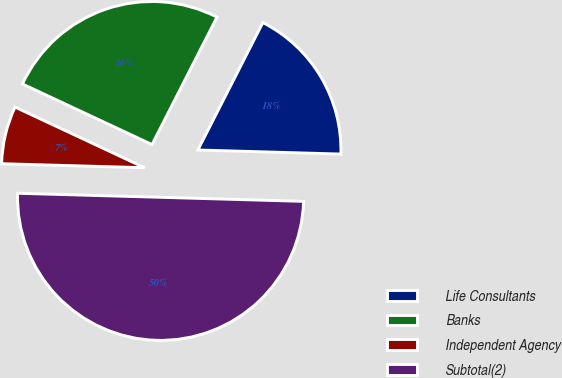Convert chart. <chart><loc_0><loc_0><loc_500><loc_500><pie_chart><fcel>Life Consultants<fcel>Banks<fcel>Independent Agency<fcel>Subtotal(2)<nl><fcel>17.95%<fcel>25.54%<fcel>6.52%<fcel>50.0%<nl></chart> 